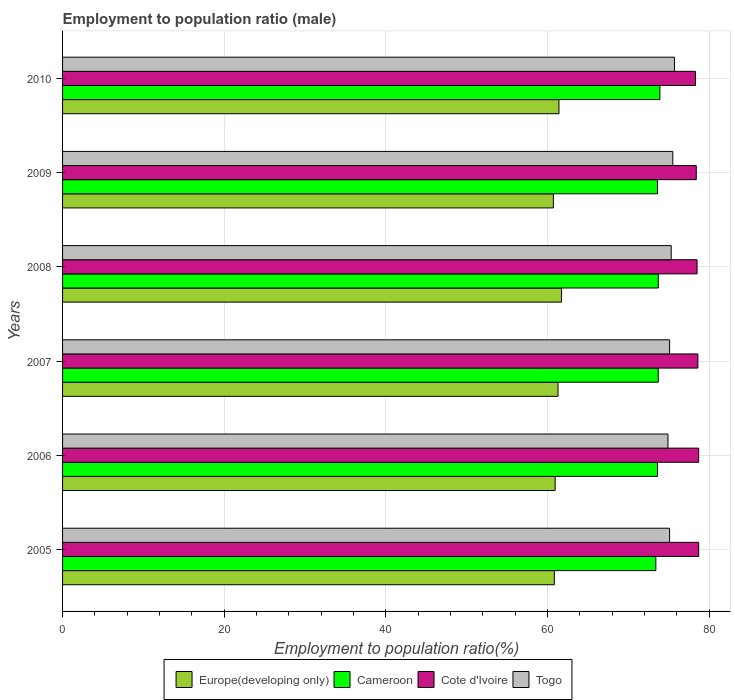How many different coloured bars are there?
Provide a short and direct response. 4. How many groups of bars are there?
Provide a succinct answer. 6. Are the number of bars on each tick of the Y-axis equal?
Provide a succinct answer. Yes. In how many cases, is the number of bars for a given year not equal to the number of legend labels?
Your answer should be compact. 0. What is the employment to population ratio in Cote d'Ivoire in 2005?
Offer a very short reply. 78.7. Across all years, what is the maximum employment to population ratio in Cote d'Ivoire?
Your answer should be very brief. 78.7. Across all years, what is the minimum employment to population ratio in Cote d'Ivoire?
Provide a succinct answer. 78.3. What is the total employment to population ratio in Cote d'Ivoire in the graph?
Provide a succinct answer. 471.2. What is the difference between the employment to population ratio in Europe(developing only) in 2007 and that in 2010?
Make the answer very short. -0.11. What is the difference between the employment to population ratio in Togo in 2009 and the employment to population ratio in Europe(developing only) in 2008?
Your answer should be very brief. 13.77. What is the average employment to population ratio in Cote d'Ivoire per year?
Keep it short and to the point. 78.53. In the year 2007, what is the difference between the employment to population ratio in Cameroon and employment to population ratio in Europe(developing only)?
Offer a terse response. 12.4. What is the ratio of the employment to population ratio in Cote d'Ivoire in 2005 to that in 2008?
Ensure brevity in your answer.  1. Is the employment to population ratio in Cote d'Ivoire in 2007 less than that in 2010?
Provide a short and direct response. No. Is the difference between the employment to population ratio in Cameroon in 2009 and 2010 greater than the difference between the employment to population ratio in Europe(developing only) in 2009 and 2010?
Make the answer very short. Yes. What is the difference between the highest and the second highest employment to population ratio in Europe(developing only)?
Make the answer very short. 0.32. What is the difference between the highest and the lowest employment to population ratio in Cameroon?
Keep it short and to the point. 0.5. Is the sum of the employment to population ratio in Cameroon in 2007 and 2009 greater than the maximum employment to population ratio in Europe(developing only) across all years?
Ensure brevity in your answer.  Yes. What does the 1st bar from the top in 2010 represents?
Provide a short and direct response. Togo. What does the 2nd bar from the bottom in 2010 represents?
Your answer should be very brief. Cameroon. How many years are there in the graph?
Give a very brief answer. 6. What is the difference between two consecutive major ticks on the X-axis?
Give a very brief answer. 20. Where does the legend appear in the graph?
Provide a succinct answer. Bottom center. What is the title of the graph?
Your response must be concise. Employment to population ratio (male). What is the label or title of the X-axis?
Keep it short and to the point. Employment to population ratio(%). What is the label or title of the Y-axis?
Your answer should be compact. Years. What is the Employment to population ratio(%) of Europe(developing only) in 2005?
Make the answer very short. 60.84. What is the Employment to population ratio(%) of Cameroon in 2005?
Offer a terse response. 73.4. What is the Employment to population ratio(%) of Cote d'Ivoire in 2005?
Offer a terse response. 78.7. What is the Employment to population ratio(%) in Togo in 2005?
Offer a terse response. 75.1. What is the Employment to population ratio(%) of Europe(developing only) in 2006?
Offer a very short reply. 60.94. What is the Employment to population ratio(%) in Cameroon in 2006?
Your answer should be compact. 73.6. What is the Employment to population ratio(%) of Cote d'Ivoire in 2006?
Offer a terse response. 78.7. What is the Employment to population ratio(%) of Togo in 2006?
Your answer should be very brief. 74.9. What is the Employment to population ratio(%) of Europe(developing only) in 2007?
Keep it short and to the point. 61.3. What is the Employment to population ratio(%) in Cameroon in 2007?
Your response must be concise. 73.7. What is the Employment to population ratio(%) in Cote d'Ivoire in 2007?
Make the answer very short. 78.6. What is the Employment to population ratio(%) in Togo in 2007?
Provide a succinct answer. 75.1. What is the Employment to population ratio(%) of Europe(developing only) in 2008?
Provide a short and direct response. 61.73. What is the Employment to population ratio(%) of Cameroon in 2008?
Your answer should be very brief. 73.7. What is the Employment to population ratio(%) of Cote d'Ivoire in 2008?
Your answer should be compact. 78.5. What is the Employment to population ratio(%) in Togo in 2008?
Your answer should be compact. 75.3. What is the Employment to population ratio(%) of Europe(developing only) in 2009?
Your answer should be very brief. 60.72. What is the Employment to population ratio(%) in Cameroon in 2009?
Keep it short and to the point. 73.6. What is the Employment to population ratio(%) of Cote d'Ivoire in 2009?
Ensure brevity in your answer.  78.4. What is the Employment to population ratio(%) of Togo in 2009?
Your response must be concise. 75.5. What is the Employment to population ratio(%) of Europe(developing only) in 2010?
Your answer should be very brief. 61.41. What is the Employment to population ratio(%) in Cameroon in 2010?
Keep it short and to the point. 73.9. What is the Employment to population ratio(%) in Cote d'Ivoire in 2010?
Your answer should be compact. 78.3. What is the Employment to population ratio(%) of Togo in 2010?
Your answer should be compact. 75.7. Across all years, what is the maximum Employment to population ratio(%) of Europe(developing only)?
Give a very brief answer. 61.73. Across all years, what is the maximum Employment to population ratio(%) of Cameroon?
Ensure brevity in your answer.  73.9. Across all years, what is the maximum Employment to population ratio(%) of Cote d'Ivoire?
Provide a succinct answer. 78.7. Across all years, what is the maximum Employment to population ratio(%) of Togo?
Your response must be concise. 75.7. Across all years, what is the minimum Employment to population ratio(%) in Europe(developing only)?
Offer a terse response. 60.72. Across all years, what is the minimum Employment to population ratio(%) in Cameroon?
Ensure brevity in your answer.  73.4. Across all years, what is the minimum Employment to population ratio(%) in Cote d'Ivoire?
Provide a succinct answer. 78.3. Across all years, what is the minimum Employment to population ratio(%) in Togo?
Your answer should be very brief. 74.9. What is the total Employment to population ratio(%) of Europe(developing only) in the graph?
Offer a very short reply. 366.95. What is the total Employment to population ratio(%) of Cameroon in the graph?
Your answer should be very brief. 441.9. What is the total Employment to population ratio(%) of Cote d'Ivoire in the graph?
Your response must be concise. 471.2. What is the total Employment to population ratio(%) in Togo in the graph?
Ensure brevity in your answer.  451.6. What is the difference between the Employment to population ratio(%) in Europe(developing only) in 2005 and that in 2006?
Offer a terse response. -0.1. What is the difference between the Employment to population ratio(%) of Europe(developing only) in 2005 and that in 2007?
Provide a short and direct response. -0.46. What is the difference between the Employment to population ratio(%) of Cameroon in 2005 and that in 2007?
Provide a short and direct response. -0.3. What is the difference between the Employment to population ratio(%) of Europe(developing only) in 2005 and that in 2008?
Your answer should be very brief. -0.89. What is the difference between the Employment to population ratio(%) in Cameroon in 2005 and that in 2008?
Give a very brief answer. -0.3. What is the difference between the Employment to population ratio(%) of Togo in 2005 and that in 2008?
Provide a short and direct response. -0.2. What is the difference between the Employment to population ratio(%) of Europe(developing only) in 2005 and that in 2009?
Ensure brevity in your answer.  0.12. What is the difference between the Employment to population ratio(%) of Cameroon in 2005 and that in 2009?
Ensure brevity in your answer.  -0.2. What is the difference between the Employment to population ratio(%) in Cote d'Ivoire in 2005 and that in 2009?
Make the answer very short. 0.3. What is the difference between the Employment to population ratio(%) of Togo in 2005 and that in 2009?
Offer a terse response. -0.4. What is the difference between the Employment to population ratio(%) in Europe(developing only) in 2005 and that in 2010?
Ensure brevity in your answer.  -0.57. What is the difference between the Employment to population ratio(%) in Cameroon in 2005 and that in 2010?
Offer a terse response. -0.5. What is the difference between the Employment to population ratio(%) in Togo in 2005 and that in 2010?
Provide a short and direct response. -0.6. What is the difference between the Employment to population ratio(%) of Europe(developing only) in 2006 and that in 2007?
Your answer should be very brief. -0.36. What is the difference between the Employment to population ratio(%) of Cameroon in 2006 and that in 2007?
Provide a succinct answer. -0.1. What is the difference between the Employment to population ratio(%) in Togo in 2006 and that in 2007?
Make the answer very short. -0.2. What is the difference between the Employment to population ratio(%) of Europe(developing only) in 2006 and that in 2008?
Give a very brief answer. -0.79. What is the difference between the Employment to population ratio(%) of Cameroon in 2006 and that in 2008?
Your response must be concise. -0.1. What is the difference between the Employment to population ratio(%) of Togo in 2006 and that in 2008?
Keep it short and to the point. -0.4. What is the difference between the Employment to population ratio(%) in Europe(developing only) in 2006 and that in 2009?
Provide a succinct answer. 0.22. What is the difference between the Employment to population ratio(%) in Europe(developing only) in 2006 and that in 2010?
Your response must be concise. -0.47. What is the difference between the Employment to population ratio(%) in Europe(developing only) in 2007 and that in 2008?
Keep it short and to the point. -0.44. What is the difference between the Employment to population ratio(%) of Togo in 2007 and that in 2008?
Provide a succinct answer. -0.2. What is the difference between the Employment to population ratio(%) of Europe(developing only) in 2007 and that in 2009?
Provide a short and direct response. 0.58. What is the difference between the Employment to population ratio(%) in Cote d'Ivoire in 2007 and that in 2009?
Provide a short and direct response. 0.2. What is the difference between the Employment to population ratio(%) in Europe(developing only) in 2007 and that in 2010?
Your response must be concise. -0.11. What is the difference between the Employment to population ratio(%) in Cote d'Ivoire in 2007 and that in 2010?
Offer a terse response. 0.3. What is the difference between the Employment to population ratio(%) in Europe(developing only) in 2008 and that in 2009?
Ensure brevity in your answer.  1.01. What is the difference between the Employment to population ratio(%) of Cameroon in 2008 and that in 2009?
Your answer should be very brief. 0.1. What is the difference between the Employment to population ratio(%) in Cote d'Ivoire in 2008 and that in 2009?
Your response must be concise. 0.1. What is the difference between the Employment to population ratio(%) in Europe(developing only) in 2008 and that in 2010?
Your answer should be compact. 0.32. What is the difference between the Employment to population ratio(%) of Togo in 2008 and that in 2010?
Provide a short and direct response. -0.4. What is the difference between the Employment to population ratio(%) of Europe(developing only) in 2009 and that in 2010?
Provide a short and direct response. -0.69. What is the difference between the Employment to population ratio(%) of Cameroon in 2009 and that in 2010?
Offer a very short reply. -0.3. What is the difference between the Employment to population ratio(%) of Cote d'Ivoire in 2009 and that in 2010?
Provide a short and direct response. 0.1. What is the difference between the Employment to population ratio(%) of Togo in 2009 and that in 2010?
Your response must be concise. -0.2. What is the difference between the Employment to population ratio(%) of Europe(developing only) in 2005 and the Employment to population ratio(%) of Cameroon in 2006?
Ensure brevity in your answer.  -12.76. What is the difference between the Employment to population ratio(%) in Europe(developing only) in 2005 and the Employment to population ratio(%) in Cote d'Ivoire in 2006?
Your answer should be compact. -17.86. What is the difference between the Employment to population ratio(%) of Europe(developing only) in 2005 and the Employment to population ratio(%) of Togo in 2006?
Your response must be concise. -14.06. What is the difference between the Employment to population ratio(%) in Cameroon in 2005 and the Employment to population ratio(%) in Cote d'Ivoire in 2006?
Give a very brief answer. -5.3. What is the difference between the Employment to population ratio(%) in Cote d'Ivoire in 2005 and the Employment to population ratio(%) in Togo in 2006?
Your response must be concise. 3.8. What is the difference between the Employment to population ratio(%) in Europe(developing only) in 2005 and the Employment to population ratio(%) in Cameroon in 2007?
Your answer should be compact. -12.86. What is the difference between the Employment to population ratio(%) of Europe(developing only) in 2005 and the Employment to population ratio(%) of Cote d'Ivoire in 2007?
Your answer should be compact. -17.76. What is the difference between the Employment to population ratio(%) of Europe(developing only) in 2005 and the Employment to population ratio(%) of Togo in 2007?
Provide a short and direct response. -14.26. What is the difference between the Employment to population ratio(%) in Cameroon in 2005 and the Employment to population ratio(%) in Cote d'Ivoire in 2007?
Make the answer very short. -5.2. What is the difference between the Employment to population ratio(%) in Cameroon in 2005 and the Employment to population ratio(%) in Togo in 2007?
Keep it short and to the point. -1.7. What is the difference between the Employment to population ratio(%) of Europe(developing only) in 2005 and the Employment to population ratio(%) of Cameroon in 2008?
Your answer should be very brief. -12.86. What is the difference between the Employment to population ratio(%) in Europe(developing only) in 2005 and the Employment to population ratio(%) in Cote d'Ivoire in 2008?
Offer a terse response. -17.66. What is the difference between the Employment to population ratio(%) of Europe(developing only) in 2005 and the Employment to population ratio(%) of Togo in 2008?
Ensure brevity in your answer.  -14.46. What is the difference between the Employment to population ratio(%) in Cameroon in 2005 and the Employment to population ratio(%) in Togo in 2008?
Keep it short and to the point. -1.9. What is the difference between the Employment to population ratio(%) of Europe(developing only) in 2005 and the Employment to population ratio(%) of Cameroon in 2009?
Offer a very short reply. -12.76. What is the difference between the Employment to population ratio(%) in Europe(developing only) in 2005 and the Employment to population ratio(%) in Cote d'Ivoire in 2009?
Your response must be concise. -17.56. What is the difference between the Employment to population ratio(%) of Europe(developing only) in 2005 and the Employment to population ratio(%) of Togo in 2009?
Make the answer very short. -14.66. What is the difference between the Employment to population ratio(%) in Cameroon in 2005 and the Employment to population ratio(%) in Togo in 2009?
Give a very brief answer. -2.1. What is the difference between the Employment to population ratio(%) of Europe(developing only) in 2005 and the Employment to population ratio(%) of Cameroon in 2010?
Give a very brief answer. -13.06. What is the difference between the Employment to population ratio(%) of Europe(developing only) in 2005 and the Employment to population ratio(%) of Cote d'Ivoire in 2010?
Your answer should be compact. -17.46. What is the difference between the Employment to population ratio(%) of Europe(developing only) in 2005 and the Employment to population ratio(%) of Togo in 2010?
Keep it short and to the point. -14.86. What is the difference between the Employment to population ratio(%) of Europe(developing only) in 2006 and the Employment to population ratio(%) of Cameroon in 2007?
Make the answer very short. -12.76. What is the difference between the Employment to population ratio(%) of Europe(developing only) in 2006 and the Employment to population ratio(%) of Cote d'Ivoire in 2007?
Provide a succinct answer. -17.66. What is the difference between the Employment to population ratio(%) in Europe(developing only) in 2006 and the Employment to population ratio(%) in Togo in 2007?
Your response must be concise. -14.16. What is the difference between the Employment to population ratio(%) in Cote d'Ivoire in 2006 and the Employment to population ratio(%) in Togo in 2007?
Provide a short and direct response. 3.6. What is the difference between the Employment to population ratio(%) of Europe(developing only) in 2006 and the Employment to population ratio(%) of Cameroon in 2008?
Provide a short and direct response. -12.76. What is the difference between the Employment to population ratio(%) in Europe(developing only) in 2006 and the Employment to population ratio(%) in Cote d'Ivoire in 2008?
Keep it short and to the point. -17.56. What is the difference between the Employment to population ratio(%) of Europe(developing only) in 2006 and the Employment to population ratio(%) of Togo in 2008?
Make the answer very short. -14.36. What is the difference between the Employment to population ratio(%) in Cote d'Ivoire in 2006 and the Employment to population ratio(%) in Togo in 2008?
Your answer should be compact. 3.4. What is the difference between the Employment to population ratio(%) of Europe(developing only) in 2006 and the Employment to population ratio(%) of Cameroon in 2009?
Your answer should be compact. -12.66. What is the difference between the Employment to population ratio(%) of Europe(developing only) in 2006 and the Employment to population ratio(%) of Cote d'Ivoire in 2009?
Your answer should be compact. -17.46. What is the difference between the Employment to population ratio(%) in Europe(developing only) in 2006 and the Employment to population ratio(%) in Togo in 2009?
Provide a short and direct response. -14.56. What is the difference between the Employment to population ratio(%) in Cameroon in 2006 and the Employment to population ratio(%) in Cote d'Ivoire in 2009?
Make the answer very short. -4.8. What is the difference between the Employment to population ratio(%) of Cameroon in 2006 and the Employment to population ratio(%) of Togo in 2009?
Make the answer very short. -1.9. What is the difference between the Employment to population ratio(%) in Europe(developing only) in 2006 and the Employment to population ratio(%) in Cameroon in 2010?
Your response must be concise. -12.96. What is the difference between the Employment to population ratio(%) in Europe(developing only) in 2006 and the Employment to population ratio(%) in Cote d'Ivoire in 2010?
Keep it short and to the point. -17.36. What is the difference between the Employment to population ratio(%) in Europe(developing only) in 2006 and the Employment to population ratio(%) in Togo in 2010?
Offer a terse response. -14.76. What is the difference between the Employment to population ratio(%) of Cameroon in 2006 and the Employment to population ratio(%) of Cote d'Ivoire in 2010?
Ensure brevity in your answer.  -4.7. What is the difference between the Employment to population ratio(%) in Cameroon in 2006 and the Employment to population ratio(%) in Togo in 2010?
Your answer should be compact. -2.1. What is the difference between the Employment to population ratio(%) of Cote d'Ivoire in 2006 and the Employment to population ratio(%) of Togo in 2010?
Your answer should be compact. 3. What is the difference between the Employment to population ratio(%) in Europe(developing only) in 2007 and the Employment to population ratio(%) in Cameroon in 2008?
Offer a terse response. -12.4. What is the difference between the Employment to population ratio(%) of Europe(developing only) in 2007 and the Employment to population ratio(%) of Cote d'Ivoire in 2008?
Make the answer very short. -17.2. What is the difference between the Employment to population ratio(%) in Europe(developing only) in 2007 and the Employment to population ratio(%) in Togo in 2008?
Your answer should be compact. -14. What is the difference between the Employment to population ratio(%) of Cameroon in 2007 and the Employment to population ratio(%) of Cote d'Ivoire in 2008?
Your answer should be very brief. -4.8. What is the difference between the Employment to population ratio(%) in Cote d'Ivoire in 2007 and the Employment to population ratio(%) in Togo in 2008?
Make the answer very short. 3.3. What is the difference between the Employment to population ratio(%) of Europe(developing only) in 2007 and the Employment to population ratio(%) of Cameroon in 2009?
Ensure brevity in your answer.  -12.3. What is the difference between the Employment to population ratio(%) in Europe(developing only) in 2007 and the Employment to population ratio(%) in Cote d'Ivoire in 2009?
Provide a succinct answer. -17.1. What is the difference between the Employment to population ratio(%) of Europe(developing only) in 2007 and the Employment to population ratio(%) of Togo in 2009?
Your answer should be very brief. -14.2. What is the difference between the Employment to population ratio(%) of Cote d'Ivoire in 2007 and the Employment to population ratio(%) of Togo in 2009?
Keep it short and to the point. 3.1. What is the difference between the Employment to population ratio(%) in Europe(developing only) in 2007 and the Employment to population ratio(%) in Cameroon in 2010?
Your answer should be compact. -12.6. What is the difference between the Employment to population ratio(%) of Europe(developing only) in 2007 and the Employment to population ratio(%) of Cote d'Ivoire in 2010?
Your response must be concise. -17. What is the difference between the Employment to population ratio(%) in Europe(developing only) in 2007 and the Employment to population ratio(%) in Togo in 2010?
Provide a succinct answer. -14.4. What is the difference between the Employment to population ratio(%) of Cote d'Ivoire in 2007 and the Employment to population ratio(%) of Togo in 2010?
Provide a succinct answer. 2.9. What is the difference between the Employment to population ratio(%) in Europe(developing only) in 2008 and the Employment to population ratio(%) in Cameroon in 2009?
Your response must be concise. -11.87. What is the difference between the Employment to population ratio(%) of Europe(developing only) in 2008 and the Employment to population ratio(%) of Cote d'Ivoire in 2009?
Give a very brief answer. -16.67. What is the difference between the Employment to population ratio(%) in Europe(developing only) in 2008 and the Employment to population ratio(%) in Togo in 2009?
Make the answer very short. -13.77. What is the difference between the Employment to population ratio(%) of Cameroon in 2008 and the Employment to population ratio(%) of Cote d'Ivoire in 2009?
Your response must be concise. -4.7. What is the difference between the Employment to population ratio(%) in Cote d'Ivoire in 2008 and the Employment to population ratio(%) in Togo in 2009?
Ensure brevity in your answer.  3. What is the difference between the Employment to population ratio(%) in Europe(developing only) in 2008 and the Employment to population ratio(%) in Cameroon in 2010?
Your answer should be very brief. -12.17. What is the difference between the Employment to population ratio(%) of Europe(developing only) in 2008 and the Employment to population ratio(%) of Cote d'Ivoire in 2010?
Make the answer very short. -16.57. What is the difference between the Employment to population ratio(%) of Europe(developing only) in 2008 and the Employment to population ratio(%) of Togo in 2010?
Your answer should be compact. -13.97. What is the difference between the Employment to population ratio(%) of Cameroon in 2008 and the Employment to population ratio(%) of Cote d'Ivoire in 2010?
Make the answer very short. -4.6. What is the difference between the Employment to population ratio(%) of Europe(developing only) in 2009 and the Employment to population ratio(%) of Cameroon in 2010?
Make the answer very short. -13.18. What is the difference between the Employment to population ratio(%) of Europe(developing only) in 2009 and the Employment to population ratio(%) of Cote d'Ivoire in 2010?
Your answer should be compact. -17.58. What is the difference between the Employment to population ratio(%) in Europe(developing only) in 2009 and the Employment to population ratio(%) in Togo in 2010?
Make the answer very short. -14.98. What is the difference between the Employment to population ratio(%) in Cote d'Ivoire in 2009 and the Employment to population ratio(%) in Togo in 2010?
Your response must be concise. 2.7. What is the average Employment to population ratio(%) in Europe(developing only) per year?
Your response must be concise. 61.16. What is the average Employment to population ratio(%) of Cameroon per year?
Offer a very short reply. 73.65. What is the average Employment to population ratio(%) of Cote d'Ivoire per year?
Provide a short and direct response. 78.53. What is the average Employment to population ratio(%) of Togo per year?
Give a very brief answer. 75.27. In the year 2005, what is the difference between the Employment to population ratio(%) in Europe(developing only) and Employment to population ratio(%) in Cameroon?
Offer a very short reply. -12.56. In the year 2005, what is the difference between the Employment to population ratio(%) of Europe(developing only) and Employment to population ratio(%) of Cote d'Ivoire?
Your answer should be very brief. -17.86. In the year 2005, what is the difference between the Employment to population ratio(%) of Europe(developing only) and Employment to population ratio(%) of Togo?
Keep it short and to the point. -14.26. In the year 2006, what is the difference between the Employment to population ratio(%) of Europe(developing only) and Employment to population ratio(%) of Cameroon?
Keep it short and to the point. -12.66. In the year 2006, what is the difference between the Employment to population ratio(%) in Europe(developing only) and Employment to population ratio(%) in Cote d'Ivoire?
Ensure brevity in your answer.  -17.76. In the year 2006, what is the difference between the Employment to population ratio(%) in Europe(developing only) and Employment to population ratio(%) in Togo?
Keep it short and to the point. -13.96. In the year 2006, what is the difference between the Employment to population ratio(%) in Cameroon and Employment to population ratio(%) in Cote d'Ivoire?
Your answer should be very brief. -5.1. In the year 2006, what is the difference between the Employment to population ratio(%) in Cameroon and Employment to population ratio(%) in Togo?
Your answer should be compact. -1.3. In the year 2006, what is the difference between the Employment to population ratio(%) of Cote d'Ivoire and Employment to population ratio(%) of Togo?
Offer a terse response. 3.8. In the year 2007, what is the difference between the Employment to population ratio(%) in Europe(developing only) and Employment to population ratio(%) in Cameroon?
Offer a terse response. -12.4. In the year 2007, what is the difference between the Employment to population ratio(%) in Europe(developing only) and Employment to population ratio(%) in Cote d'Ivoire?
Keep it short and to the point. -17.3. In the year 2007, what is the difference between the Employment to population ratio(%) of Europe(developing only) and Employment to population ratio(%) of Togo?
Provide a succinct answer. -13.8. In the year 2007, what is the difference between the Employment to population ratio(%) of Cameroon and Employment to population ratio(%) of Cote d'Ivoire?
Your response must be concise. -4.9. In the year 2007, what is the difference between the Employment to population ratio(%) in Cameroon and Employment to population ratio(%) in Togo?
Your response must be concise. -1.4. In the year 2007, what is the difference between the Employment to population ratio(%) in Cote d'Ivoire and Employment to population ratio(%) in Togo?
Ensure brevity in your answer.  3.5. In the year 2008, what is the difference between the Employment to population ratio(%) in Europe(developing only) and Employment to population ratio(%) in Cameroon?
Provide a succinct answer. -11.97. In the year 2008, what is the difference between the Employment to population ratio(%) of Europe(developing only) and Employment to population ratio(%) of Cote d'Ivoire?
Your answer should be very brief. -16.77. In the year 2008, what is the difference between the Employment to population ratio(%) in Europe(developing only) and Employment to population ratio(%) in Togo?
Your response must be concise. -13.57. In the year 2008, what is the difference between the Employment to population ratio(%) in Cote d'Ivoire and Employment to population ratio(%) in Togo?
Make the answer very short. 3.2. In the year 2009, what is the difference between the Employment to population ratio(%) in Europe(developing only) and Employment to population ratio(%) in Cameroon?
Offer a terse response. -12.88. In the year 2009, what is the difference between the Employment to population ratio(%) of Europe(developing only) and Employment to population ratio(%) of Cote d'Ivoire?
Your answer should be very brief. -17.68. In the year 2009, what is the difference between the Employment to population ratio(%) in Europe(developing only) and Employment to population ratio(%) in Togo?
Make the answer very short. -14.78. In the year 2010, what is the difference between the Employment to population ratio(%) of Europe(developing only) and Employment to population ratio(%) of Cameroon?
Offer a very short reply. -12.49. In the year 2010, what is the difference between the Employment to population ratio(%) in Europe(developing only) and Employment to population ratio(%) in Cote d'Ivoire?
Ensure brevity in your answer.  -16.89. In the year 2010, what is the difference between the Employment to population ratio(%) in Europe(developing only) and Employment to population ratio(%) in Togo?
Your answer should be compact. -14.29. In the year 2010, what is the difference between the Employment to population ratio(%) of Cameroon and Employment to population ratio(%) of Cote d'Ivoire?
Your answer should be very brief. -4.4. What is the ratio of the Employment to population ratio(%) of Cote d'Ivoire in 2005 to that in 2006?
Keep it short and to the point. 1. What is the ratio of the Employment to population ratio(%) of Togo in 2005 to that in 2006?
Provide a short and direct response. 1. What is the ratio of the Employment to population ratio(%) in Cote d'Ivoire in 2005 to that in 2007?
Ensure brevity in your answer.  1. What is the ratio of the Employment to population ratio(%) in Togo in 2005 to that in 2007?
Keep it short and to the point. 1. What is the ratio of the Employment to population ratio(%) in Europe(developing only) in 2005 to that in 2008?
Provide a short and direct response. 0.99. What is the ratio of the Employment to population ratio(%) in Europe(developing only) in 2005 to that in 2009?
Your response must be concise. 1. What is the ratio of the Employment to population ratio(%) of Cameroon in 2005 to that in 2009?
Provide a short and direct response. 1. What is the ratio of the Employment to population ratio(%) in Cote d'Ivoire in 2005 to that in 2009?
Offer a terse response. 1. What is the ratio of the Employment to population ratio(%) of Togo in 2005 to that in 2009?
Give a very brief answer. 0.99. What is the ratio of the Employment to population ratio(%) in Europe(developing only) in 2005 to that in 2010?
Provide a succinct answer. 0.99. What is the ratio of the Employment to population ratio(%) in Europe(developing only) in 2006 to that in 2007?
Ensure brevity in your answer.  0.99. What is the ratio of the Employment to population ratio(%) of Togo in 2006 to that in 2007?
Offer a very short reply. 1. What is the ratio of the Employment to population ratio(%) of Europe(developing only) in 2006 to that in 2008?
Your answer should be compact. 0.99. What is the ratio of the Employment to population ratio(%) of Cameroon in 2006 to that in 2008?
Provide a short and direct response. 1. What is the ratio of the Employment to population ratio(%) in Cote d'Ivoire in 2006 to that in 2008?
Offer a very short reply. 1. What is the ratio of the Employment to population ratio(%) of Cote d'Ivoire in 2006 to that in 2009?
Keep it short and to the point. 1. What is the ratio of the Employment to population ratio(%) of Europe(developing only) in 2006 to that in 2010?
Make the answer very short. 0.99. What is the ratio of the Employment to population ratio(%) in Cameroon in 2006 to that in 2010?
Give a very brief answer. 1. What is the ratio of the Employment to population ratio(%) of Europe(developing only) in 2007 to that in 2008?
Ensure brevity in your answer.  0.99. What is the ratio of the Employment to population ratio(%) of Cameroon in 2007 to that in 2008?
Keep it short and to the point. 1. What is the ratio of the Employment to population ratio(%) in Cote d'Ivoire in 2007 to that in 2008?
Keep it short and to the point. 1. What is the ratio of the Employment to population ratio(%) in Europe(developing only) in 2007 to that in 2009?
Make the answer very short. 1.01. What is the ratio of the Employment to population ratio(%) in Cameroon in 2007 to that in 2009?
Your answer should be compact. 1. What is the ratio of the Employment to population ratio(%) in Togo in 2007 to that in 2009?
Ensure brevity in your answer.  0.99. What is the ratio of the Employment to population ratio(%) of Europe(developing only) in 2007 to that in 2010?
Make the answer very short. 1. What is the ratio of the Employment to population ratio(%) in Cameroon in 2007 to that in 2010?
Your response must be concise. 1. What is the ratio of the Employment to population ratio(%) in Togo in 2007 to that in 2010?
Your response must be concise. 0.99. What is the ratio of the Employment to population ratio(%) in Europe(developing only) in 2008 to that in 2009?
Make the answer very short. 1.02. What is the ratio of the Employment to population ratio(%) in Cameroon in 2008 to that in 2009?
Provide a succinct answer. 1. What is the ratio of the Employment to population ratio(%) in Cote d'Ivoire in 2008 to that in 2009?
Ensure brevity in your answer.  1. What is the ratio of the Employment to population ratio(%) in Cote d'Ivoire in 2008 to that in 2010?
Provide a succinct answer. 1. What is the ratio of the Employment to population ratio(%) of Europe(developing only) in 2009 to that in 2010?
Your answer should be very brief. 0.99. What is the ratio of the Employment to population ratio(%) in Cote d'Ivoire in 2009 to that in 2010?
Offer a terse response. 1. What is the difference between the highest and the second highest Employment to population ratio(%) in Europe(developing only)?
Ensure brevity in your answer.  0.32. What is the difference between the highest and the second highest Employment to population ratio(%) of Cameroon?
Ensure brevity in your answer.  0.2. What is the difference between the highest and the lowest Employment to population ratio(%) in Europe(developing only)?
Make the answer very short. 1.01. What is the difference between the highest and the lowest Employment to population ratio(%) in Togo?
Your answer should be very brief. 0.8. 